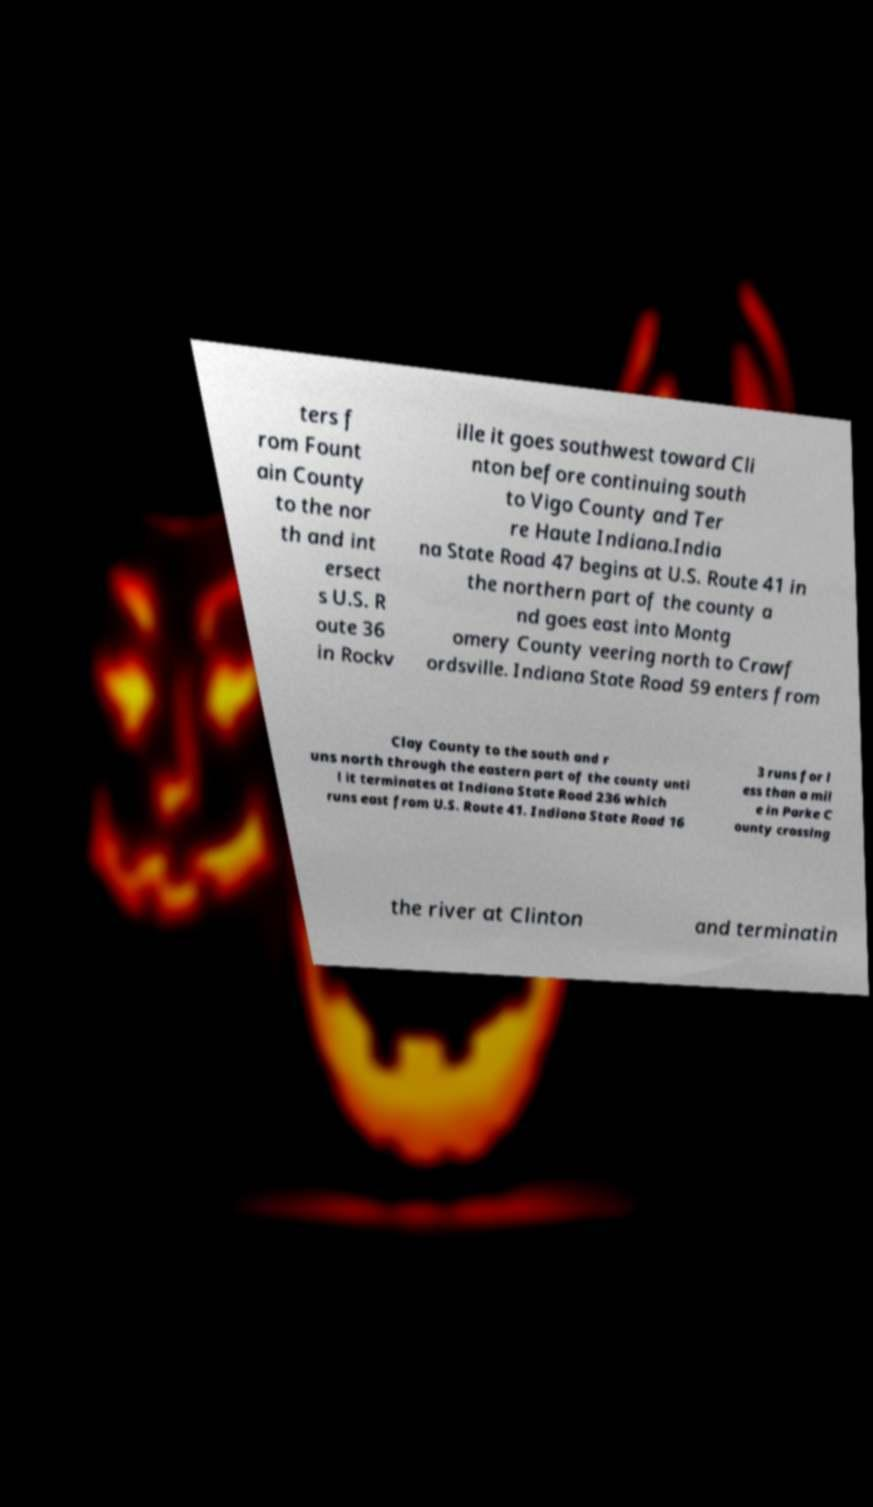Please identify and transcribe the text found in this image. ters f rom Fount ain County to the nor th and int ersect s U.S. R oute 36 in Rockv ille it goes southwest toward Cli nton before continuing south to Vigo County and Ter re Haute Indiana.India na State Road 47 begins at U.S. Route 41 in the northern part of the county a nd goes east into Montg omery County veering north to Crawf ordsville. Indiana State Road 59 enters from Clay County to the south and r uns north through the eastern part of the county unti l it terminates at Indiana State Road 236 which runs east from U.S. Route 41. Indiana State Road 16 3 runs for l ess than a mil e in Parke C ounty crossing the river at Clinton and terminatin 